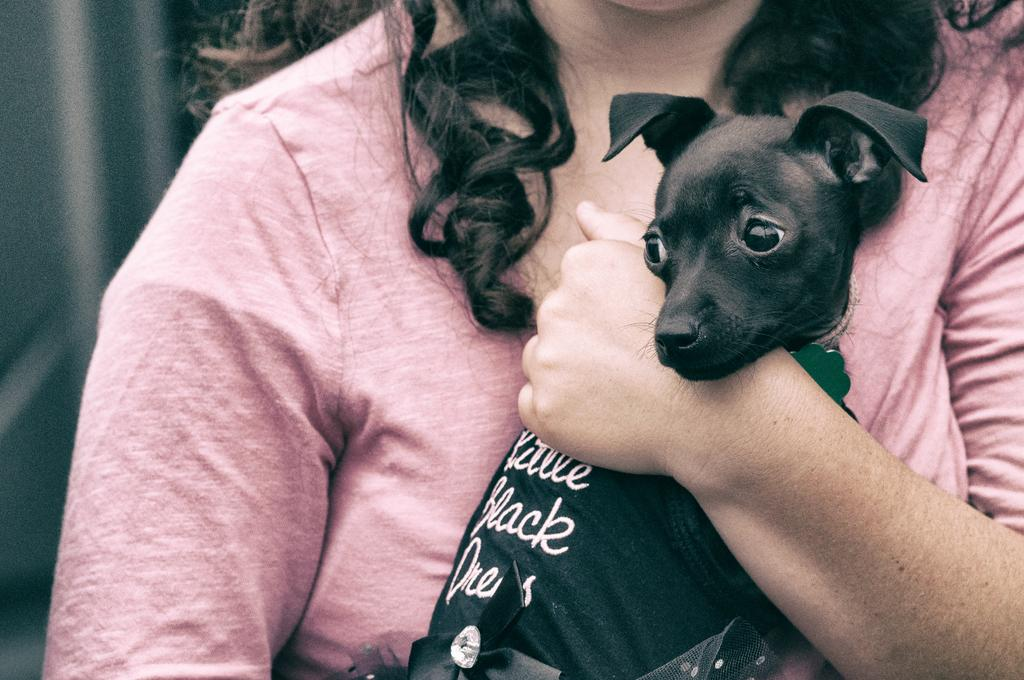Who is the main subject in the image? There is a woman in the image. What is the woman wearing? The woman is wearing a peach-colored dress. What is the woman holding in the image? The woman is holding a black dog. What time of day is depicted in the image? The time of day is not mentioned or depicted in the image. What type of hill can be seen in the background of the image? There is no hill present in the image. 